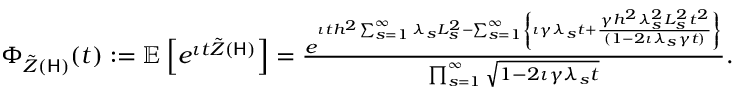Convert formula to latex. <formula><loc_0><loc_0><loc_500><loc_500>\begin{array} { r } { \Phi _ { \tilde { Z } ( H ) } ( t ) \colon = \mathbb { E } \left [ e ^ { \iota t \tilde { Z } ( H ) } \right ] = \frac { e ^ { \iota t h ^ { 2 } \sum _ { s = 1 } ^ { \infty } \lambda _ { s } L _ { s } ^ { 2 } - \sum _ { s = 1 } ^ { \infty } \left \{ \iota \gamma \lambda _ { s } t + \frac { \gamma h ^ { 2 } \lambda _ { s } ^ { 2 } L _ { s } ^ { 2 } t ^ { 2 } } { ( 1 - 2 \iota \lambda _ { s } \gamma t ) } \right \} } } { \prod _ { s = 1 } ^ { \infty } \sqrt { 1 - 2 \iota \gamma \lambda _ { s } t } } . } \end{array}</formula> 